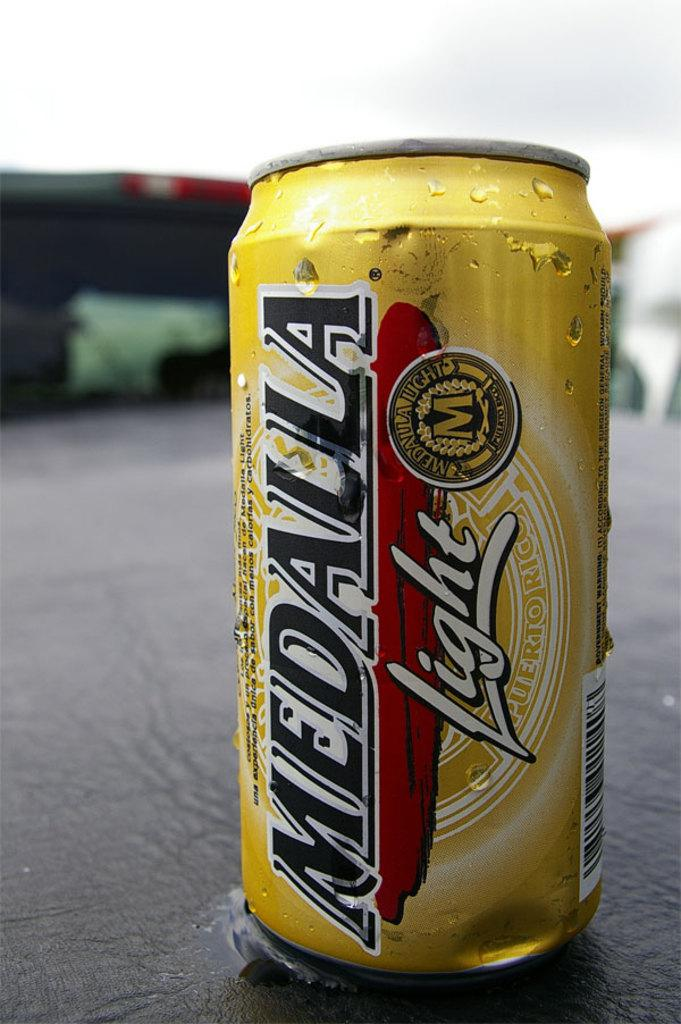<image>
Write a terse but informative summary of the picture. A Medalla light can has condensation on the side. 